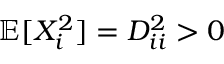Convert formula to latex. <formula><loc_0><loc_0><loc_500><loc_500>\mathbb { E } [ X _ { i } ^ { 2 } ] = D _ { i i } ^ { 2 } > 0</formula> 